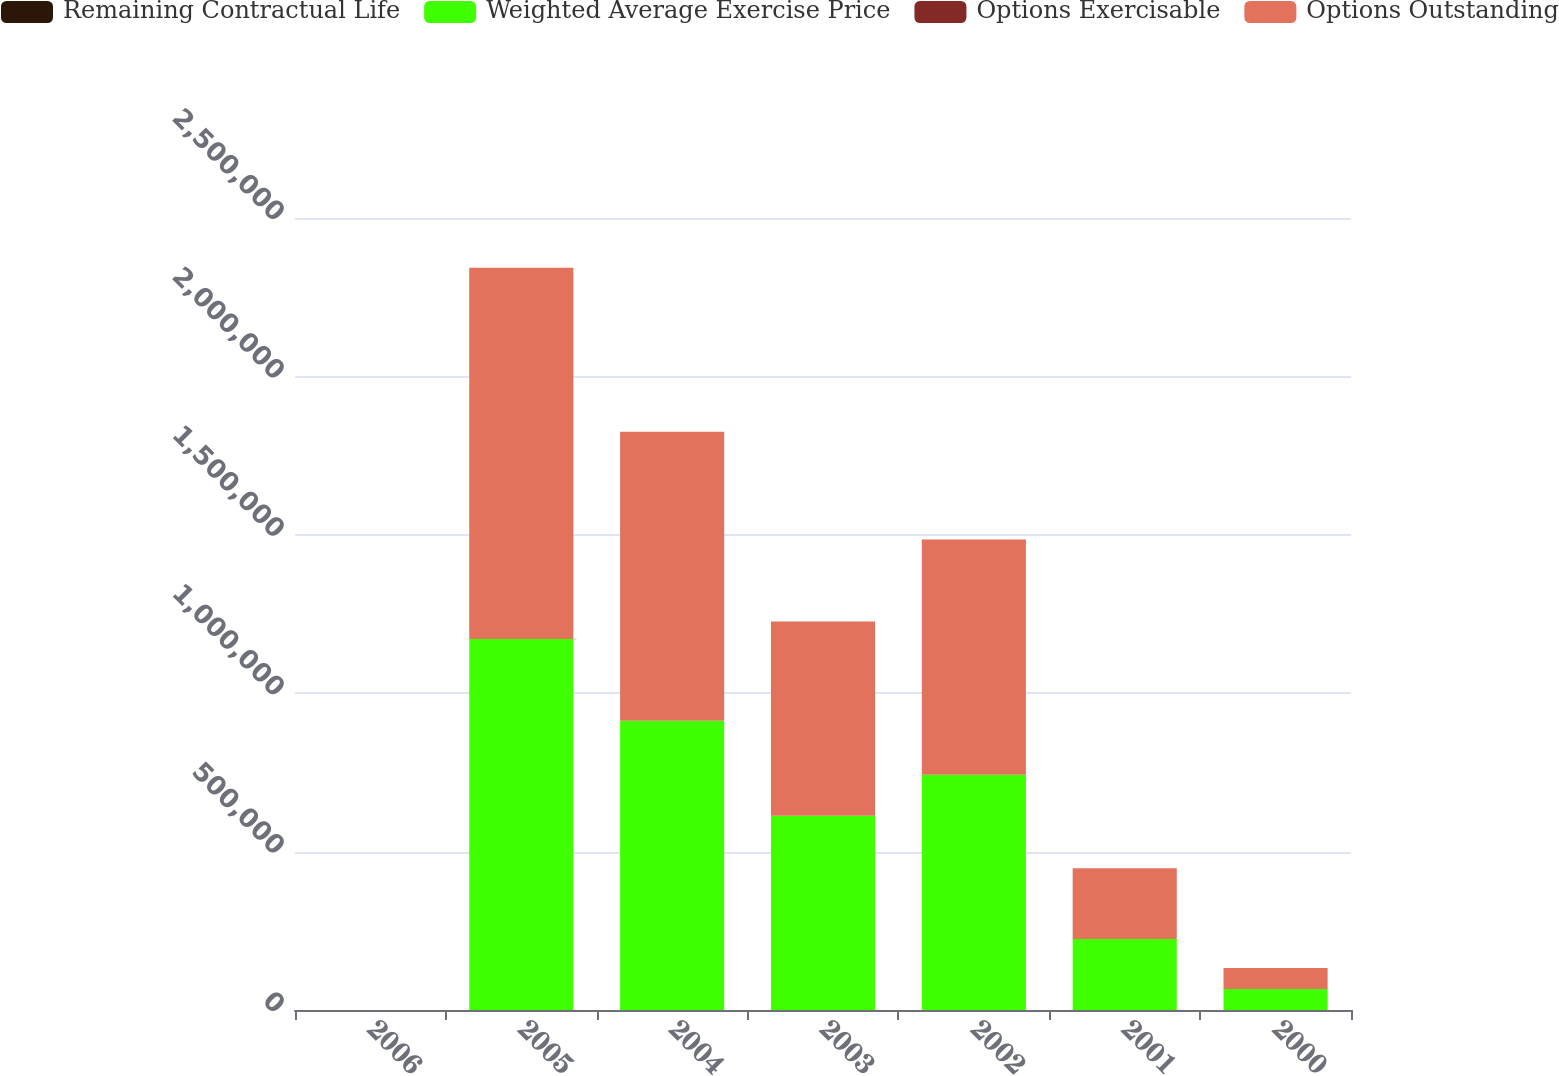Convert chart. <chart><loc_0><loc_0><loc_500><loc_500><stacked_bar_chart><ecel><fcel>2006<fcel>2005<fcel>2004<fcel>2003<fcel>2002<fcel>2001<fcel>2000<nl><fcel>Remaining Contractual Life<fcel>7<fcel>6<fcel>5<fcel>4<fcel>3<fcel>2<fcel>1<nl><fcel>Weighted Average Exercise Price<fcel>44.49<fcel>1.1714e+06<fcel>912700<fcel>613100<fcel>742550<fcel>223800<fcel>66150<nl><fcel>Options Exercisable<fcel>45.22<fcel>42.78<fcel>43.76<fcel>39.81<fcel>42.51<fcel>37.75<fcel>32.5<nl><fcel>Options Outstanding<fcel>44.49<fcel>1.1714e+06<fcel>912700<fcel>613100<fcel>742550<fcel>223800<fcel>66150<nl></chart> 